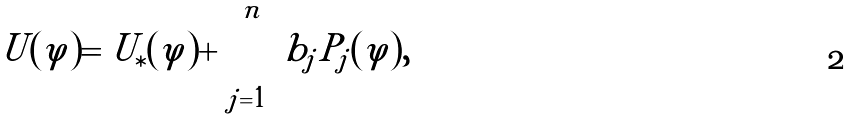<formula> <loc_0><loc_0><loc_500><loc_500>U ( \varphi ) = U _ { \ast } ( \varphi ) + \sum _ { j = 1 } ^ { n } b _ { j } \tilde { P } _ { j } ( \varphi ) ,</formula> 